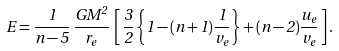Convert formula to latex. <formula><loc_0><loc_0><loc_500><loc_500>E = \frac { 1 } { n - 5 } \, \frac { G M ^ { 2 } } { r _ { e } } \, \left [ \, \frac { 3 } { 2 } \left \{ 1 - ( n + 1 ) \frac { 1 } { v _ { e } } \right \} + ( n - 2 ) \frac { u _ { e } } { v _ { e } } \, \right ] .</formula> 